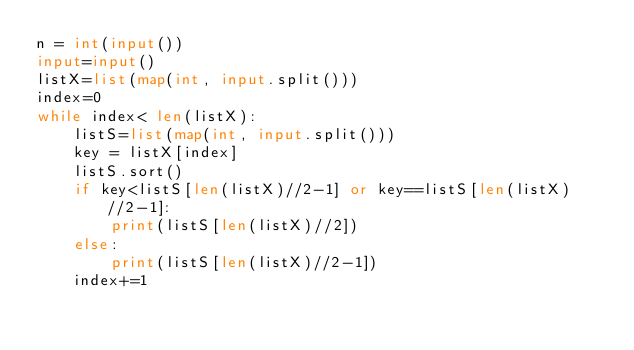Convert code to text. <code><loc_0><loc_0><loc_500><loc_500><_Python_>n = int(input())
input=input()
listX=list(map(int, input.split()))
index=0
while index< len(listX):
    listS=list(map(int, input.split()))
    key = listX[index]
    listS.sort()
    if key<listS[len(listX)//2-1] or key==listS[len(listX)//2-1]:
        print(listS[len(listX)//2])
    else:
        print(listS[len(listX)//2-1])
    index+=1</code> 